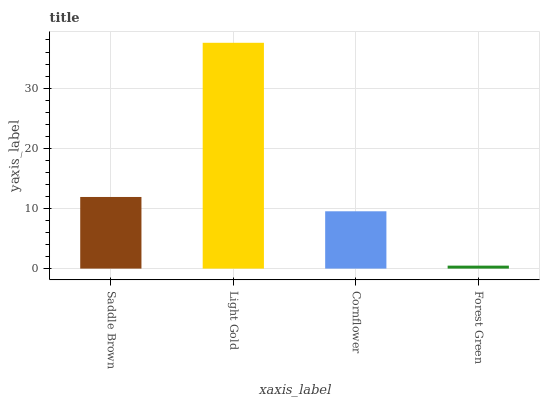Is Forest Green the minimum?
Answer yes or no. Yes. Is Light Gold the maximum?
Answer yes or no. Yes. Is Cornflower the minimum?
Answer yes or no. No. Is Cornflower the maximum?
Answer yes or no. No. Is Light Gold greater than Cornflower?
Answer yes or no. Yes. Is Cornflower less than Light Gold?
Answer yes or no. Yes. Is Cornflower greater than Light Gold?
Answer yes or no. No. Is Light Gold less than Cornflower?
Answer yes or no. No. Is Saddle Brown the high median?
Answer yes or no. Yes. Is Cornflower the low median?
Answer yes or no. Yes. Is Light Gold the high median?
Answer yes or no. No. Is Light Gold the low median?
Answer yes or no. No. 